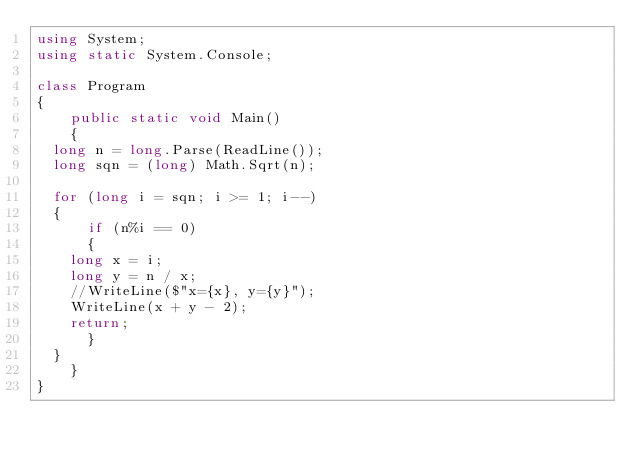Convert code to text. <code><loc_0><loc_0><loc_500><loc_500><_C#_>using System;
using static System.Console;

class Program
{
    public static void Main()
    {
	long n = long.Parse(ReadLine());
	long sqn = (long) Math.Sqrt(n);

	for (long i = sqn; i >= 1; i--)
	{
	    if (n%i == 0)
	    {
		long x = i;
		long y = n / x;
		//WriteLine($"x={x}, y={y}");
		WriteLine(x + y - 2);
		return;
	    }
	}
    }
}
</code> 